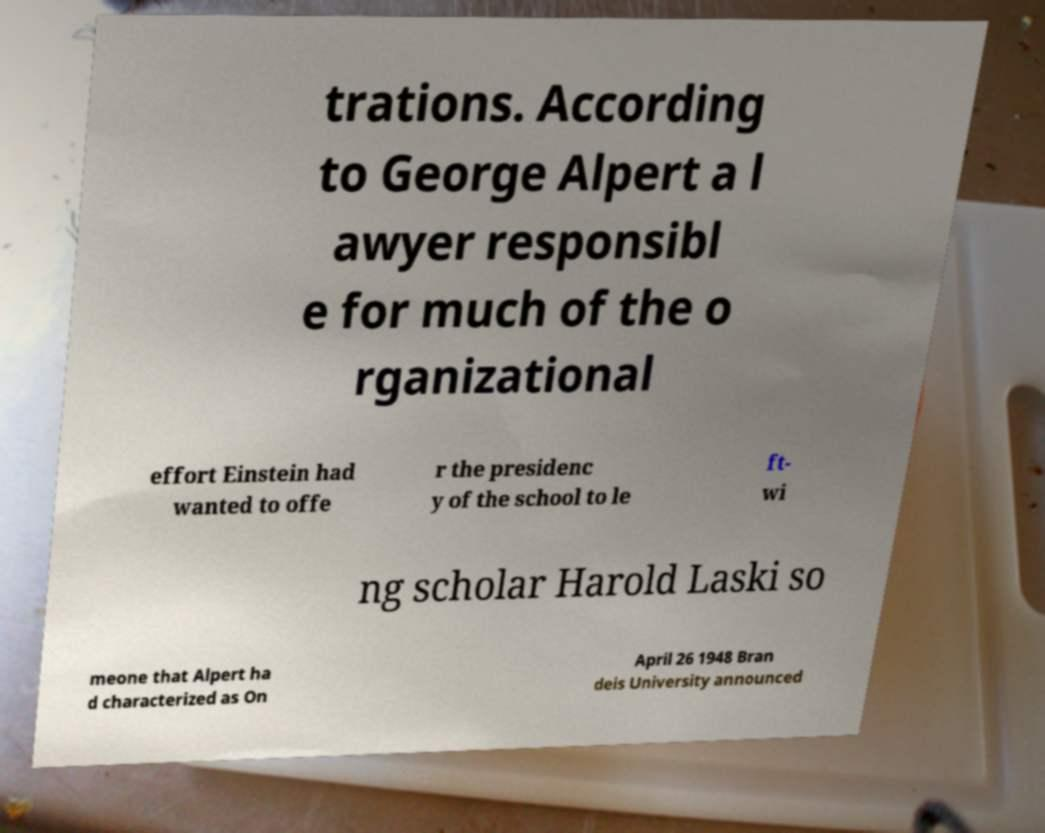I need the written content from this picture converted into text. Can you do that? trations. According to George Alpert a l awyer responsibl e for much of the o rganizational effort Einstein had wanted to offe r the presidenc y of the school to le ft- wi ng scholar Harold Laski so meone that Alpert ha d characterized as On April 26 1948 Bran deis University announced 